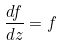<formula> <loc_0><loc_0><loc_500><loc_500>\frac { d f } { d z } = f</formula> 